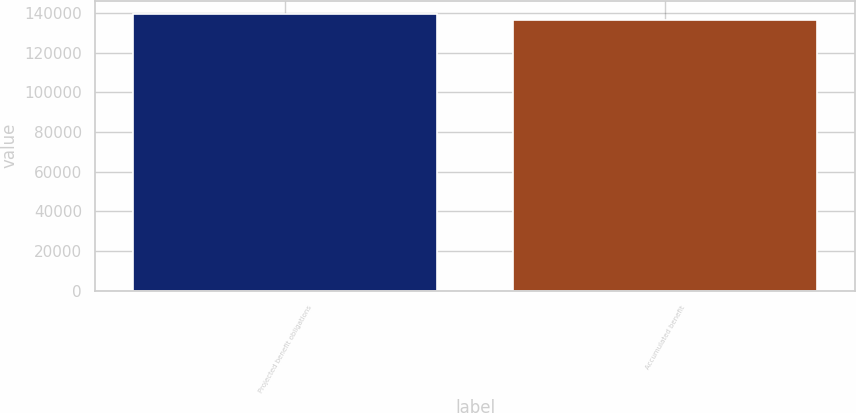<chart> <loc_0><loc_0><loc_500><loc_500><bar_chart><fcel>Projected benefit obligations<fcel>Accumulated benefit<nl><fcel>139185<fcel>136197<nl></chart> 